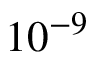Convert formula to latex. <formula><loc_0><loc_0><loc_500><loc_500>1 0 ^ { - 9 }</formula> 